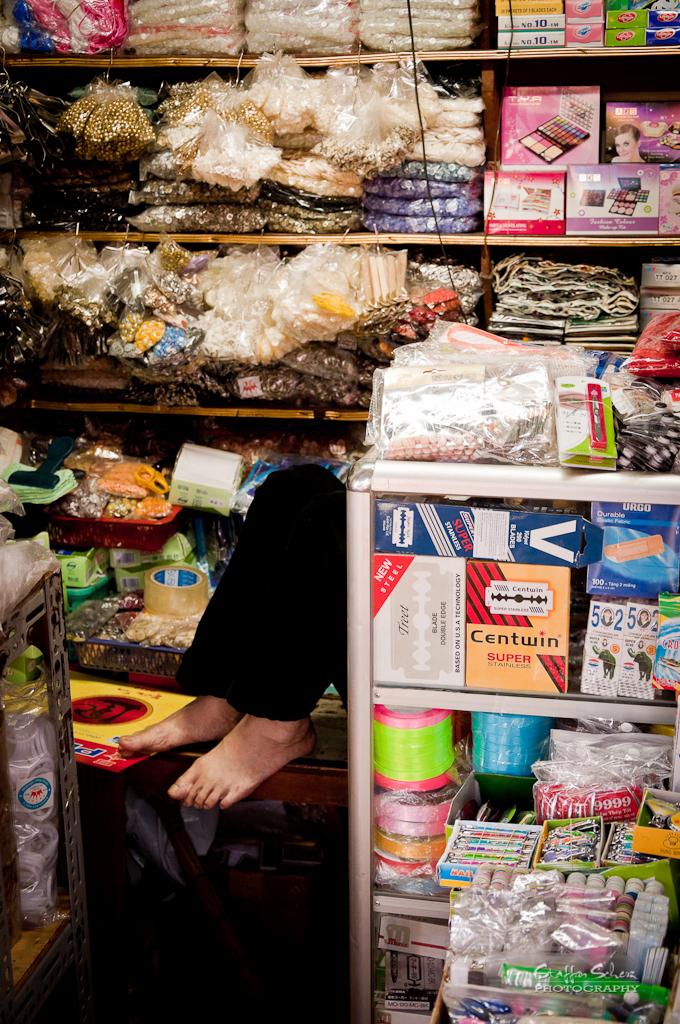What brand made the product in the orange and red package?
Your response must be concise. Centwin. What number is on the package with a bull?
Your response must be concise. 502. 